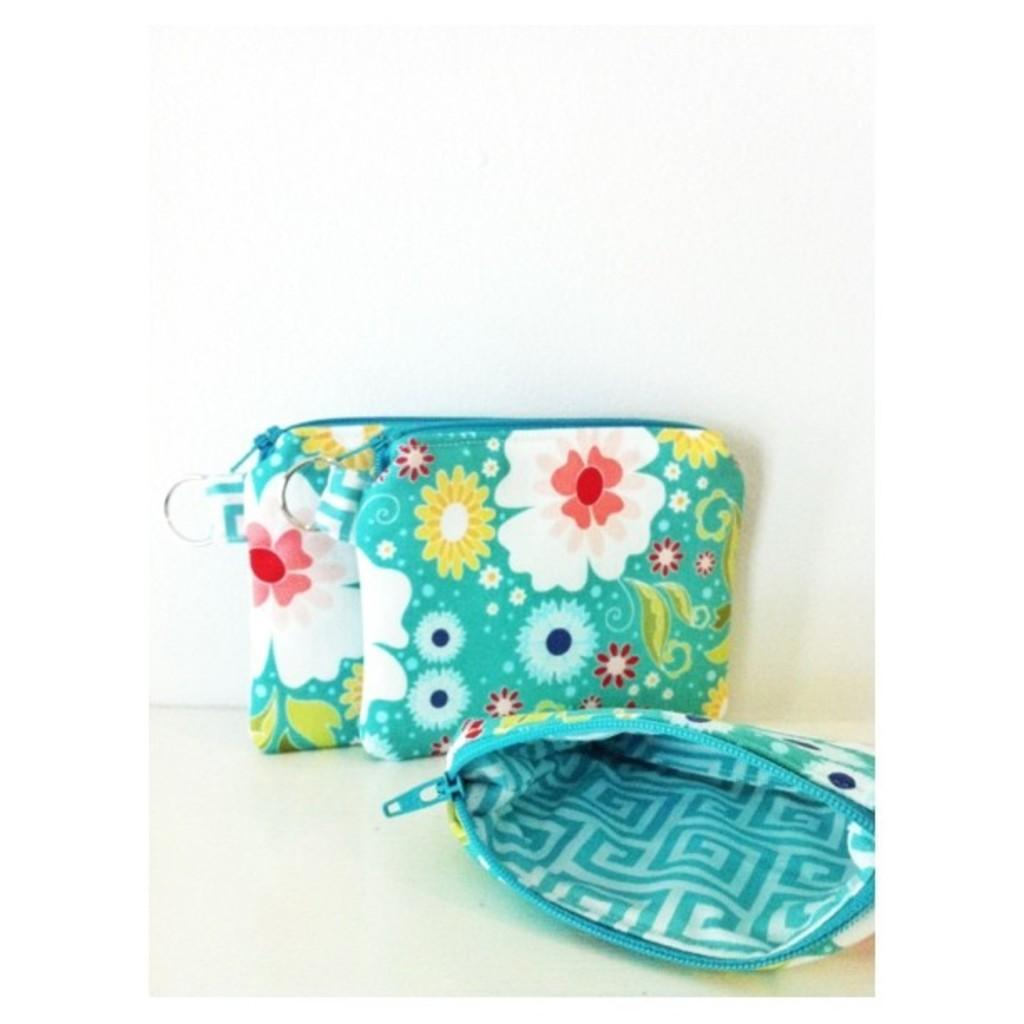How many bags are visible in the image? There are three green color bags in the image. What design is on the bags? The bags have flowers on them. Is any of the bags opened? Yes, one of the bags is opened. What color is the background of the image? The background of the image is white. How many wishes can be granted by the flowers on the bags in the image? There is no indication in the image that the flowers on the bags have any magical properties or can grant wishes. 